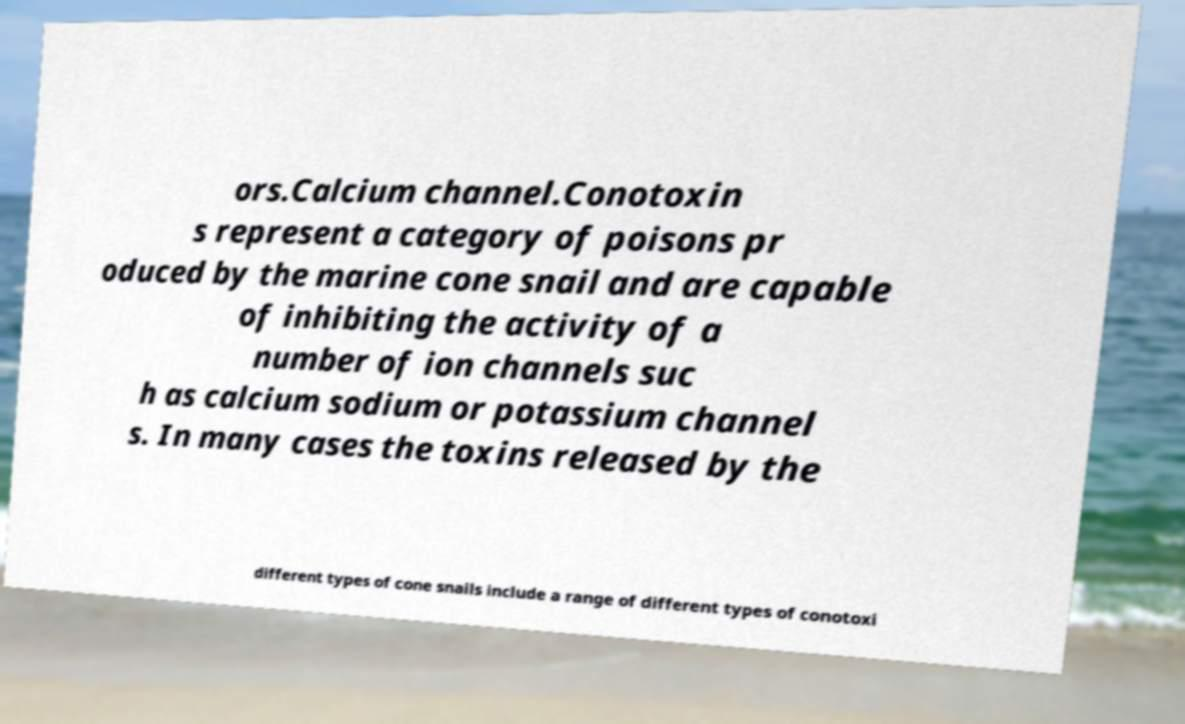Please read and relay the text visible in this image. What does it say? ors.Calcium channel.Conotoxin s represent a category of poisons pr oduced by the marine cone snail and are capable of inhibiting the activity of a number of ion channels suc h as calcium sodium or potassium channel s. In many cases the toxins released by the different types of cone snails include a range of different types of conotoxi 